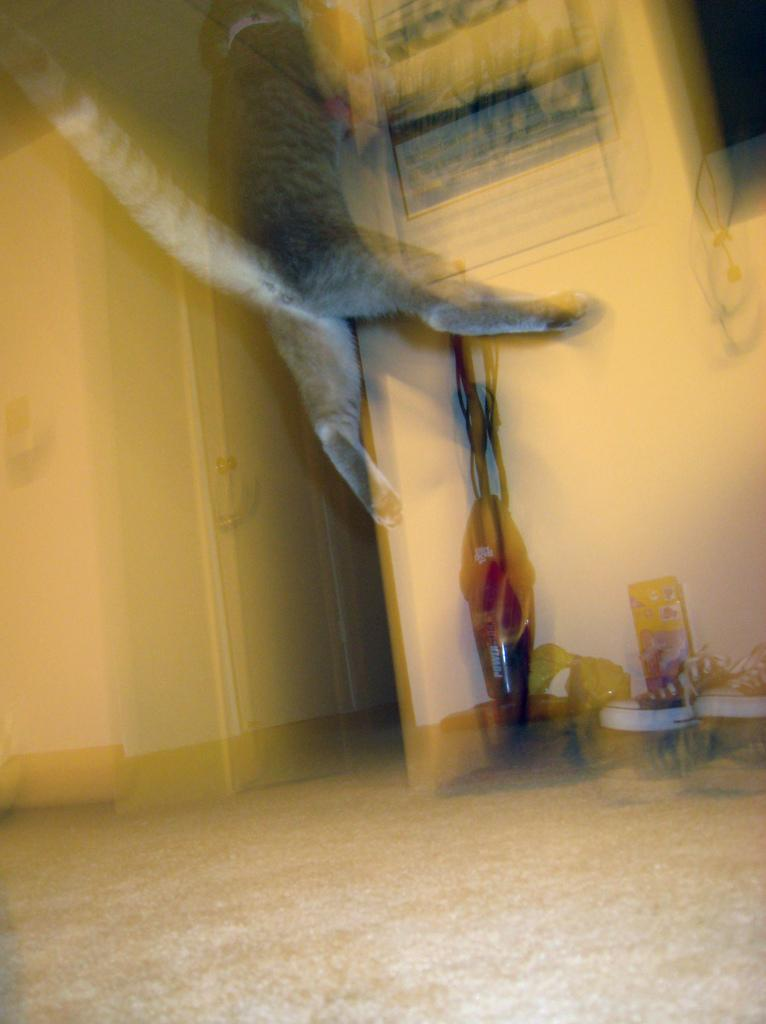What is one of the main features in the image? There is a wall in the image. What type of furniture can be seen in the image? There is a white cupboard in the image. What is on the floor in the image? There are objects on the floor in the image. How would you describe the quality of the image? The image is blurry. What is the title of the book that the spider is reading in the image? There are no spiders or books present in the image, so there is no title to mention. 